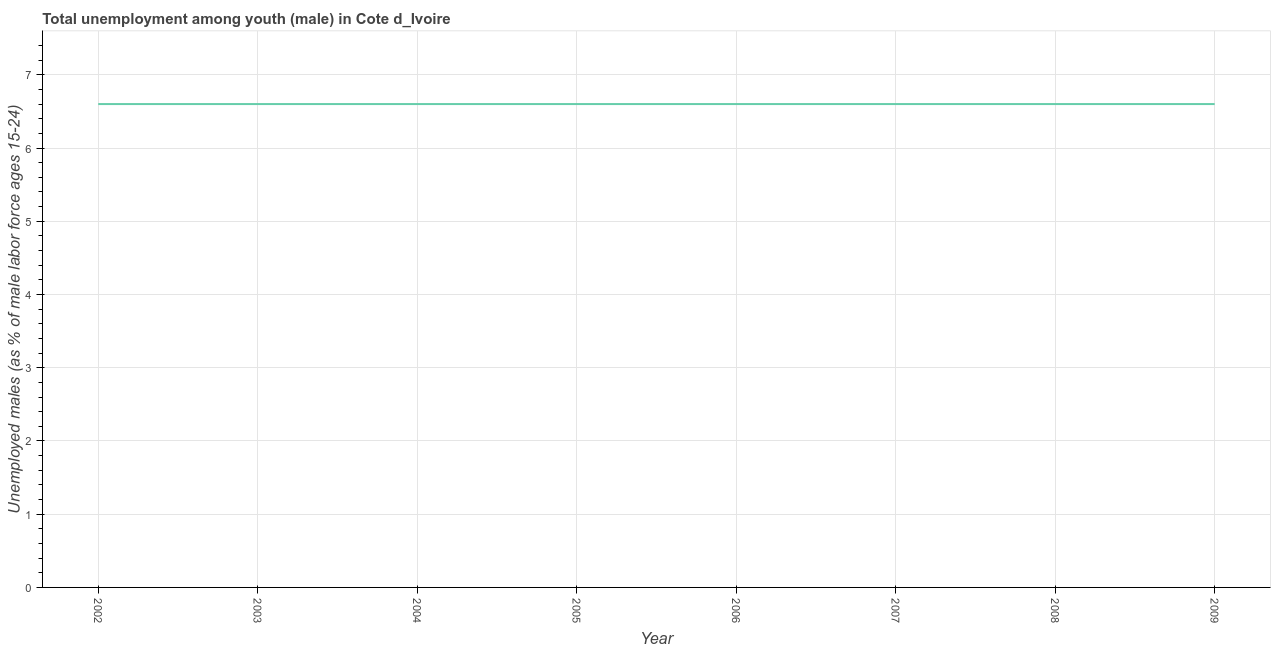What is the unemployed male youth population in 2008?
Offer a terse response. 6.6. Across all years, what is the maximum unemployed male youth population?
Provide a short and direct response. 6.6. Across all years, what is the minimum unemployed male youth population?
Your answer should be very brief. 6.6. What is the sum of the unemployed male youth population?
Offer a terse response. 52.8. What is the average unemployed male youth population per year?
Your answer should be very brief. 6.6. What is the median unemployed male youth population?
Provide a succinct answer. 6.6. What is the ratio of the unemployed male youth population in 2008 to that in 2009?
Your response must be concise. 1. Is the difference between the unemployed male youth population in 2002 and 2007 greater than the difference between any two years?
Provide a short and direct response. Yes. What is the difference between the highest and the second highest unemployed male youth population?
Give a very brief answer. 0. What is the difference between the highest and the lowest unemployed male youth population?
Your response must be concise. 0. Does the unemployed male youth population monotonically increase over the years?
Offer a terse response. No. What is the difference between two consecutive major ticks on the Y-axis?
Keep it short and to the point. 1. Does the graph contain any zero values?
Your answer should be very brief. No. Does the graph contain grids?
Your answer should be compact. Yes. What is the title of the graph?
Ensure brevity in your answer.  Total unemployment among youth (male) in Cote d_Ivoire. What is the label or title of the Y-axis?
Provide a succinct answer. Unemployed males (as % of male labor force ages 15-24). What is the Unemployed males (as % of male labor force ages 15-24) of 2002?
Keep it short and to the point. 6.6. What is the Unemployed males (as % of male labor force ages 15-24) of 2003?
Provide a short and direct response. 6.6. What is the Unemployed males (as % of male labor force ages 15-24) in 2004?
Give a very brief answer. 6.6. What is the Unemployed males (as % of male labor force ages 15-24) of 2005?
Offer a very short reply. 6.6. What is the Unemployed males (as % of male labor force ages 15-24) in 2006?
Your answer should be very brief. 6.6. What is the Unemployed males (as % of male labor force ages 15-24) in 2007?
Make the answer very short. 6.6. What is the Unemployed males (as % of male labor force ages 15-24) of 2008?
Offer a terse response. 6.6. What is the Unemployed males (as % of male labor force ages 15-24) of 2009?
Your answer should be very brief. 6.6. What is the difference between the Unemployed males (as % of male labor force ages 15-24) in 2002 and 2003?
Your answer should be very brief. 0. What is the difference between the Unemployed males (as % of male labor force ages 15-24) in 2002 and 2004?
Your answer should be compact. 0. What is the difference between the Unemployed males (as % of male labor force ages 15-24) in 2002 and 2006?
Give a very brief answer. 0. What is the difference between the Unemployed males (as % of male labor force ages 15-24) in 2002 and 2007?
Give a very brief answer. 0. What is the difference between the Unemployed males (as % of male labor force ages 15-24) in 2002 and 2008?
Ensure brevity in your answer.  0. What is the difference between the Unemployed males (as % of male labor force ages 15-24) in 2003 and 2005?
Provide a succinct answer. 0. What is the difference between the Unemployed males (as % of male labor force ages 15-24) in 2003 and 2006?
Give a very brief answer. 0. What is the difference between the Unemployed males (as % of male labor force ages 15-24) in 2004 and 2005?
Your answer should be compact. 0. What is the difference between the Unemployed males (as % of male labor force ages 15-24) in 2004 and 2006?
Provide a short and direct response. 0. What is the difference between the Unemployed males (as % of male labor force ages 15-24) in 2004 and 2008?
Make the answer very short. 0. What is the difference between the Unemployed males (as % of male labor force ages 15-24) in 2004 and 2009?
Your answer should be very brief. 0. What is the difference between the Unemployed males (as % of male labor force ages 15-24) in 2005 and 2006?
Provide a succinct answer. 0. What is the difference between the Unemployed males (as % of male labor force ages 15-24) in 2005 and 2008?
Provide a succinct answer. 0. What is the difference between the Unemployed males (as % of male labor force ages 15-24) in 2005 and 2009?
Provide a succinct answer. 0. What is the difference between the Unemployed males (as % of male labor force ages 15-24) in 2006 and 2008?
Keep it short and to the point. 0. What is the difference between the Unemployed males (as % of male labor force ages 15-24) in 2006 and 2009?
Provide a succinct answer. 0. What is the ratio of the Unemployed males (as % of male labor force ages 15-24) in 2002 to that in 2003?
Provide a succinct answer. 1. What is the ratio of the Unemployed males (as % of male labor force ages 15-24) in 2002 to that in 2004?
Provide a succinct answer. 1. What is the ratio of the Unemployed males (as % of male labor force ages 15-24) in 2002 to that in 2006?
Offer a very short reply. 1. What is the ratio of the Unemployed males (as % of male labor force ages 15-24) in 2002 to that in 2008?
Provide a short and direct response. 1. What is the ratio of the Unemployed males (as % of male labor force ages 15-24) in 2002 to that in 2009?
Keep it short and to the point. 1. What is the ratio of the Unemployed males (as % of male labor force ages 15-24) in 2003 to that in 2004?
Give a very brief answer. 1. What is the ratio of the Unemployed males (as % of male labor force ages 15-24) in 2003 to that in 2005?
Your response must be concise. 1. What is the ratio of the Unemployed males (as % of male labor force ages 15-24) in 2003 to that in 2007?
Provide a succinct answer. 1. What is the ratio of the Unemployed males (as % of male labor force ages 15-24) in 2003 to that in 2009?
Ensure brevity in your answer.  1. What is the ratio of the Unemployed males (as % of male labor force ages 15-24) in 2004 to that in 2007?
Your response must be concise. 1. What is the ratio of the Unemployed males (as % of male labor force ages 15-24) in 2004 to that in 2008?
Your answer should be very brief. 1. What is the ratio of the Unemployed males (as % of male labor force ages 15-24) in 2005 to that in 2007?
Ensure brevity in your answer.  1. What is the ratio of the Unemployed males (as % of male labor force ages 15-24) in 2006 to that in 2009?
Your response must be concise. 1. What is the ratio of the Unemployed males (as % of male labor force ages 15-24) in 2007 to that in 2009?
Keep it short and to the point. 1. 